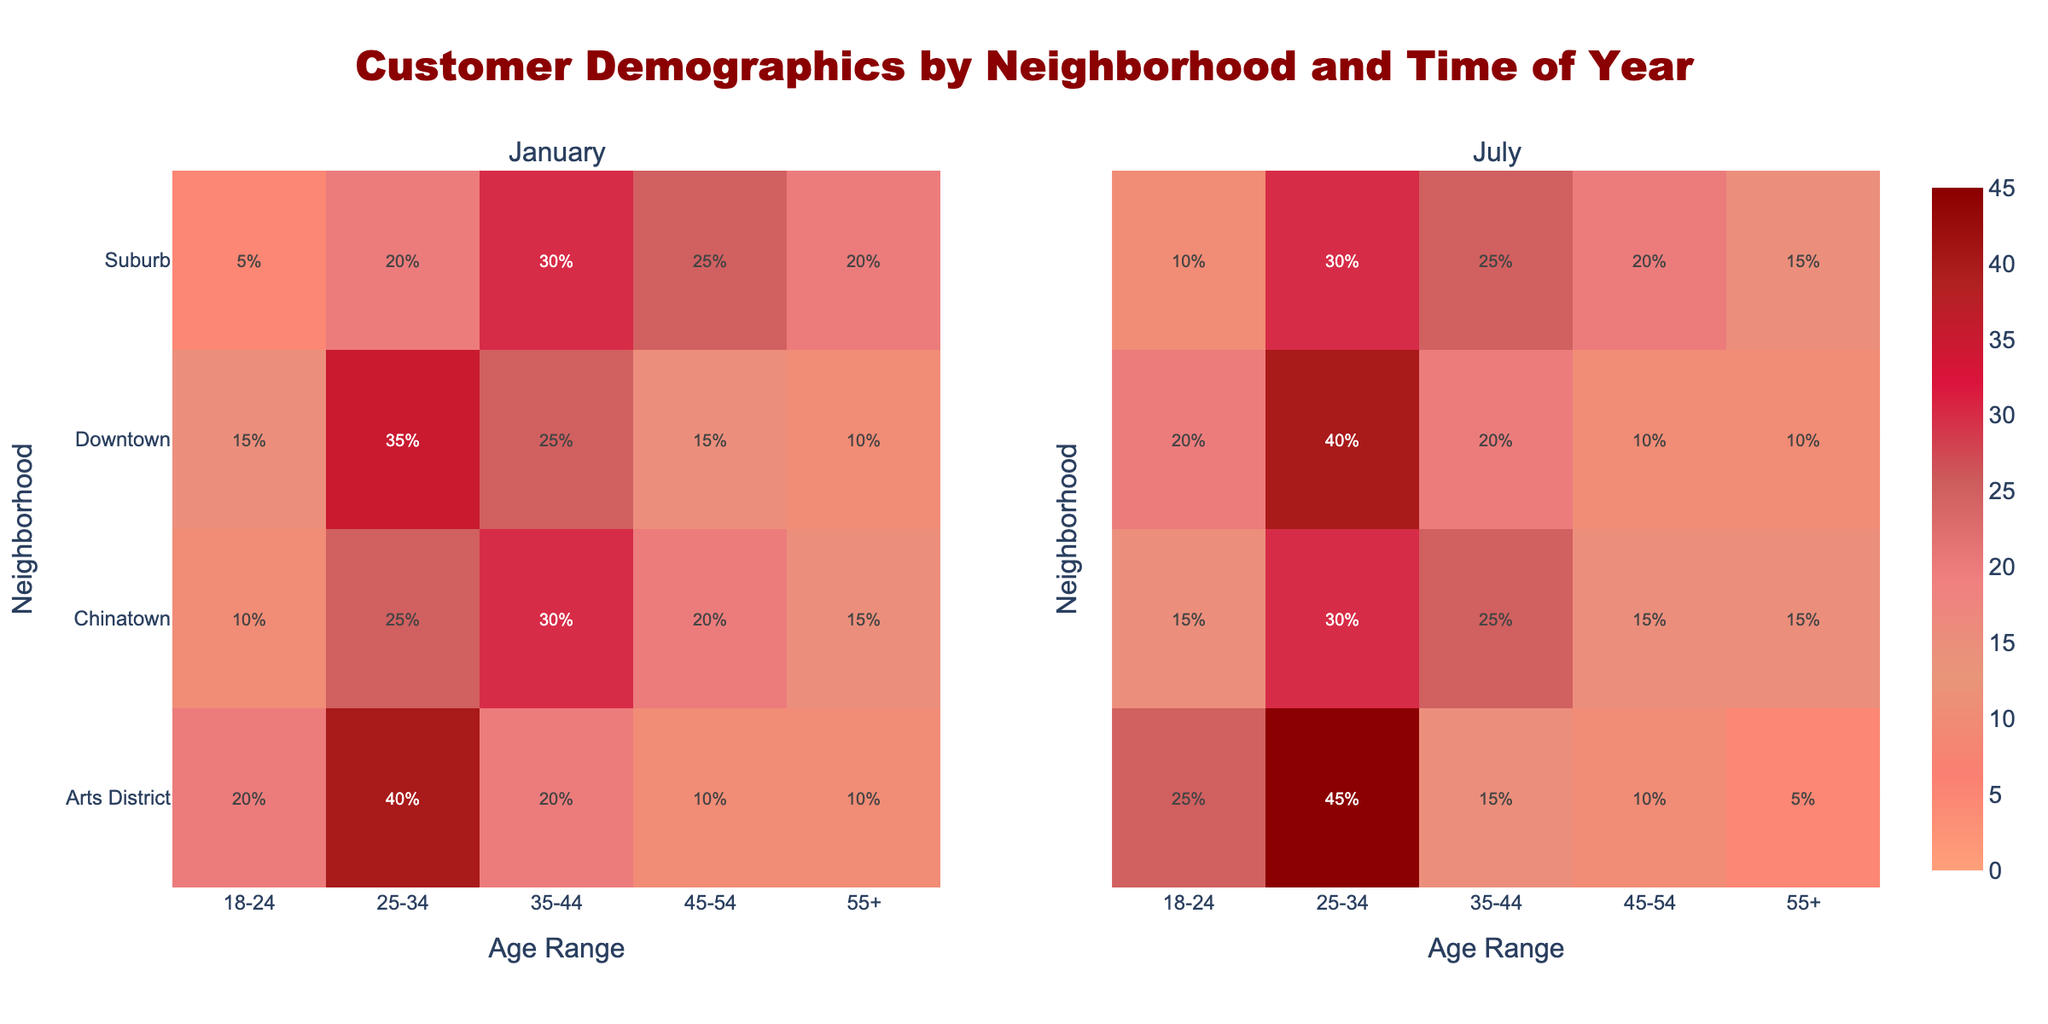Which neighborhood attracts the highest percentage of 25-34-year-olds in July? Look at the heatmap column for "25-34" and check the data for July across all neighborhoods. The highest value is in the Arts District (45%).
Answer: Arts District Is the percentage of customers aged 18-24 higher in January or July for Downtown? Compare the "18-24" age range for Downtown between January (15%) and July (20%). July has a higher percentage.
Answer: July What is the total percentage of customers aged 35-44 across all neighborhoods in January? Sum the percentages for the "35-44" age category in January across all neighborhoods: Downtown (25), Suburb (30), Chinatown (30), Arts District (20). Total: 25+30+30+20 = 105%.
Answer: 105% Which neighborhood has the most significant difference in the percentage of 45-54-year-olds between January and July? Calculate the difference between January and July for the "45-54" age category in each neighborhood: Downtown (15% - 10% = 5%), Suburb (25% - 20% = 5%), Chinatown (20% - 15% = 5%), Arts District (10% - 10% = 0%). All differences are equal at 5%.
Answer: Downtown, Suburb, Chinatown Which neighborhood has the most balanced age distribution in January? Look for a neighborhood where the percentages are more evenly spread out across age ranges in January. Chinatown has relatively balanced values: 18-24 (10), 25-34 (25), 35-44 (30), 45-54 (20), 55+ (15).
Answer: Chinatown 